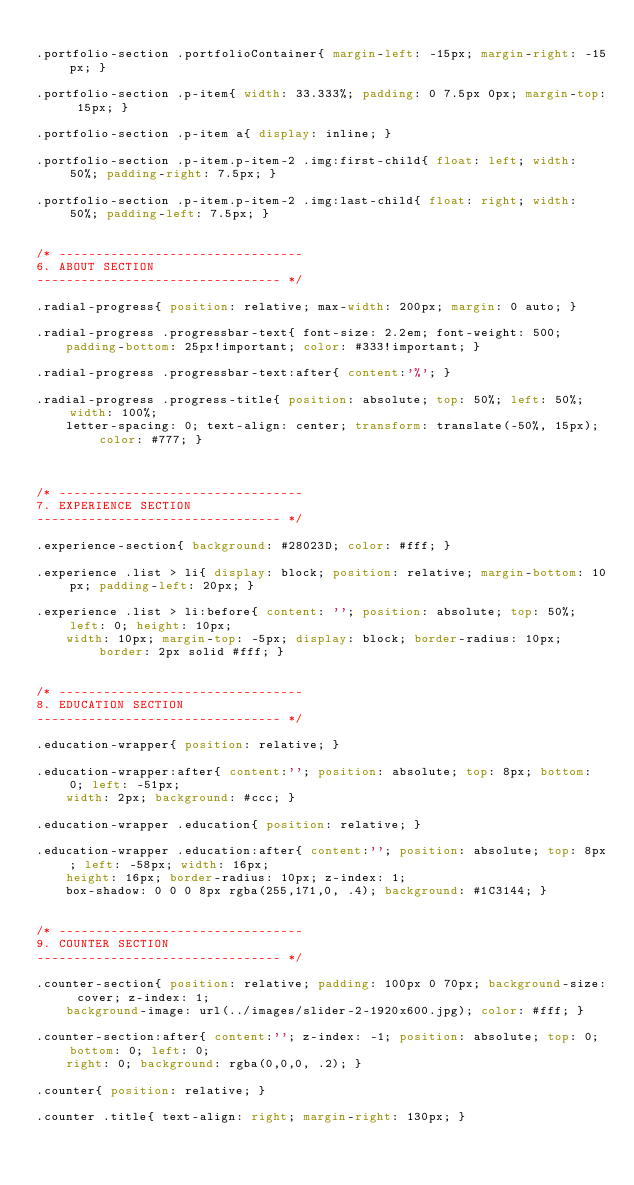<code> <loc_0><loc_0><loc_500><loc_500><_CSS_>
.portfolio-section .portfolioContainer{ margin-left: -15px; margin-right: -15px; }

.portfolio-section .p-item{ width: 33.333%; padding: 0 7.5px 0px; margin-top: 15px; }

.portfolio-section .p-item a{ display: inline; }

.portfolio-section .p-item.p-item-2 .img:first-child{ float: left; width: 50%; padding-right: 7.5px; }

.portfolio-section .p-item.p-item-2 .img:last-child{ float: right; width: 50%; padding-left: 7.5px; }


/* ---------------------------------
6. ABOUT SECTION
--------------------------------- */

.radial-progress{ position: relative; max-width: 200px; margin: 0 auto; }

.radial-progress .progressbar-text{ font-size: 2.2em; font-weight: 500; 
	padding-bottom: 25px!important; color: #333!important; }

.radial-progress .progressbar-text:after{ content:'%'; }

.radial-progress .progress-title{ position: absolute; top: 50%; left: 50%; width: 100%;
	letter-spacing: 0; text-align: center; transform: translate(-50%, 15px); color: #777; }

	

/* ---------------------------------
7. EXPERIENCE SECTION
--------------------------------- */

.experience-section{ background: #28023D; color: #fff; }

.experience .list > li{ display: block; position: relative; margin-bottom: 10px; padding-left: 20px; }

.experience .list > li:before{ content: ''; position: absolute; top: 50%; left: 0; height: 10px; 
	width: 10px; margin-top: -5px; display: block; border-radius: 10px; border: 2px solid #fff; }

	
/* ---------------------------------
8. EDUCATION SECTION
--------------------------------- */

.education-wrapper{ position: relative; }

.education-wrapper:after{ content:''; position: absolute; top: 8px; bottom: 0; left: -51px;
	width: 2px; background: #ccc; }

.education-wrapper .education{ position: relative; }

.education-wrapper .education:after{ content:''; position: absolute; top: 8px; left: -58px; width: 16px; 
	height: 16px; border-radius: 10px; z-index: 1;
	box-shadow: 0 0 0 8px rgba(255,171,0, .4); background: #1C3144; }
	
	
/* ---------------------------------
9. COUNTER SECTION
--------------------------------- */

.counter-section{ position: relative; padding: 100px 0 70px; background-size: cover; z-index: 1; 
	background-image: url(../images/slider-2-1920x600.jpg); color: #fff; }

.counter-section:after{ content:''; z-index: -1; position: absolute; top: 0; bottom: 0; left: 0; 
	right: 0; background: rgba(0,0,0, .2); }

.counter{ position: relative; }
	
.counter .title{ text-align: right; margin-right: 130px; }
</code> 